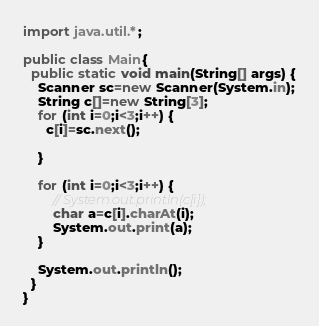<code> <loc_0><loc_0><loc_500><loc_500><_Java_>import java.util.*;

public class Main{
  public static void main(String[] args) {
    Scanner sc=new Scanner(System.in);
    String c[]=new String[3];
    for (int i=0;i<3;i++) {
      c[i]=sc.next();

    }

    for (int i=0;i<3;i++) {
        // System.out.println(c[i]);
        char a=c[i].charAt(i);
        System.out.print(a);
    }

    System.out.println();
  }
}
</code> 